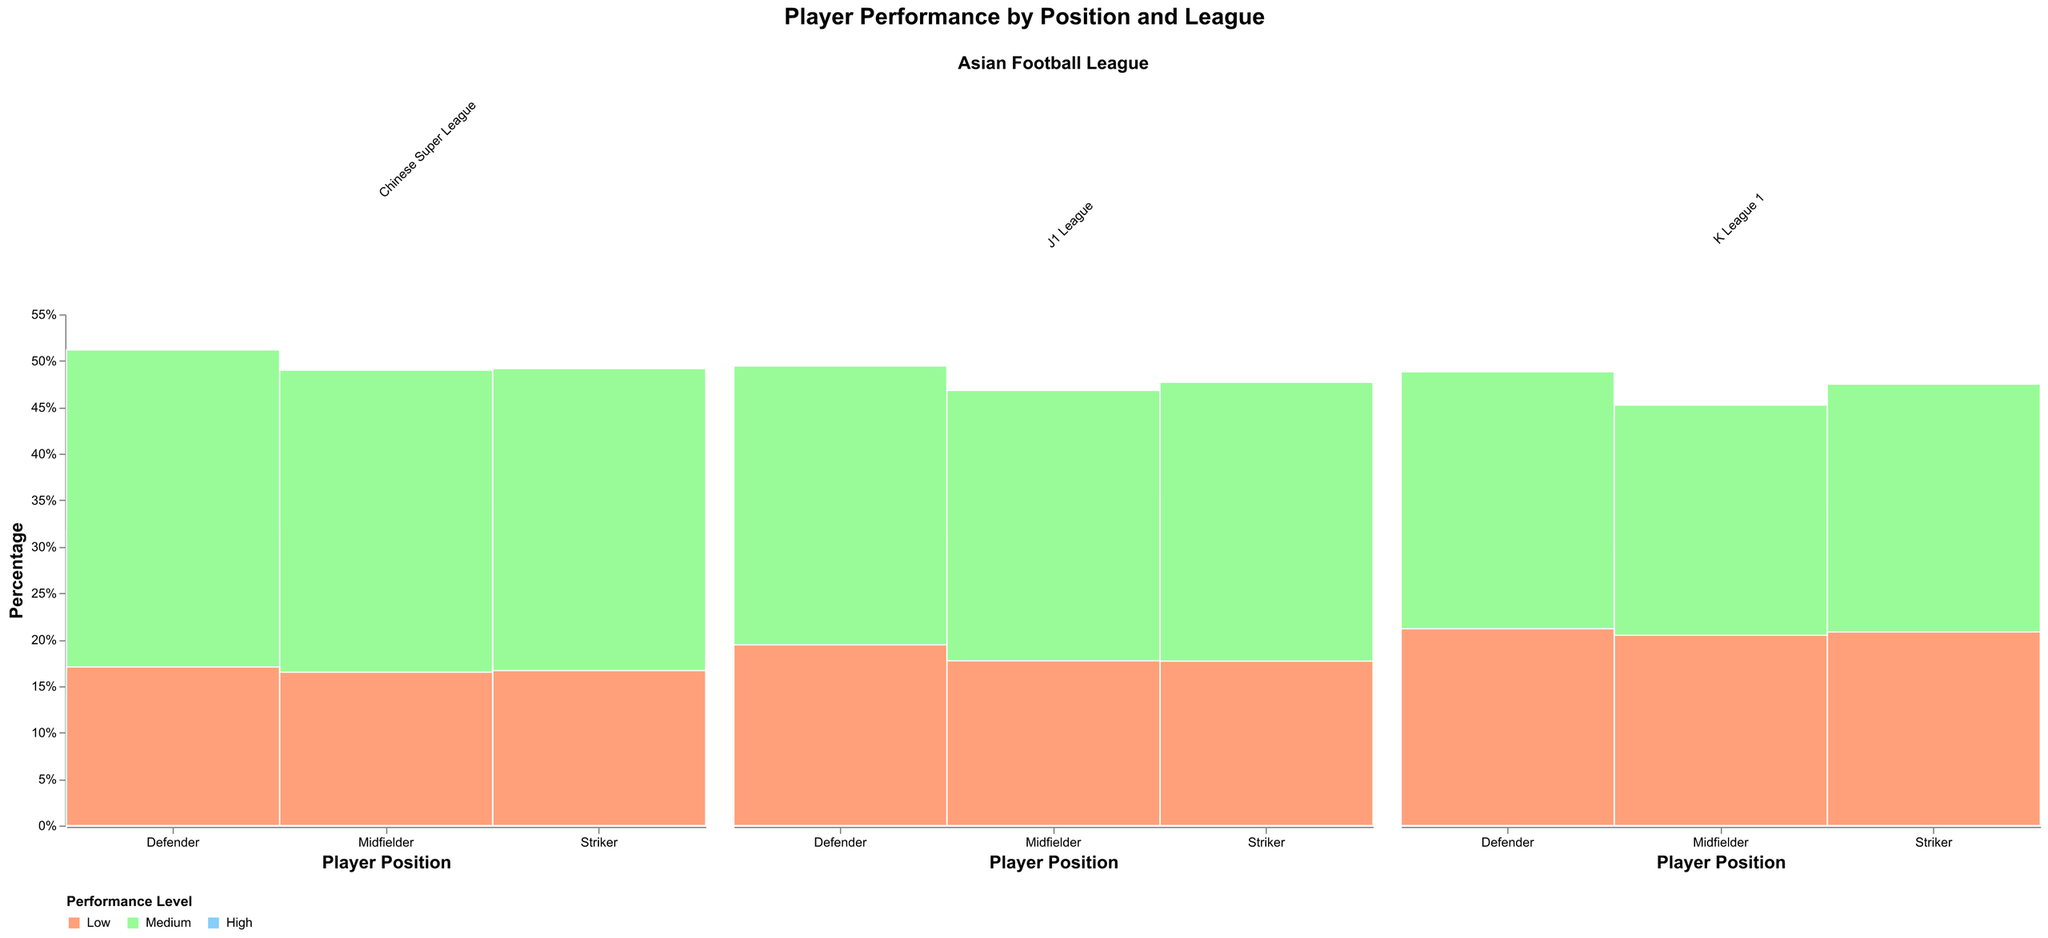Which position in the J1 League has the highest percentage of high performance? Look at the J1 League column and compare the height of the "High" performance rectangles for each position. The Midfielder has the tallest "High" segment.
Answer: Midfielder Between strikers and defenders in the K League 1, which position has a higher percentage of low performance? In the K League 1 column, the "Low" performance rectangle's height for strikers is marked. Then, compare it with the rectangle height of defenders. Strikers have a slightly higher percentage.
Answer: Strikers What is the total percentage of medium performance midfielders in the Chinese Super League? Check the Chinese Super League column. Find the "Medium" performance rectangle for midfielders, and check its height.
Answer: 49% In which league do defenders show the lowest percentage of low performance? Compare the "Low" performance rectangle's height for defenders across all leagues. The J1 League has the smallest "Low" rectangle for defenders.
Answer: J1 League How does the performance distribution of strikers differ between J1 League and K League 1? Compare the distribution (height) of "High," "Medium," and "Low" rectangles for strikers in the J1 League and K League 1 columns. In the J1 League, there are fewer highs and mediums.
Answer: Strikers in J1 League have higher lows, lower highs Which league and position combination exhibits the highest percentage of high performance? Search for the highest "High" performance rectangle across all columns and positions. Midfielders in the J1 League have the tallest "High" segment.
Answer: Midfielders in J1 League 